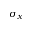<formula> <loc_0><loc_0><loc_500><loc_500>\sigma _ { x }</formula> 